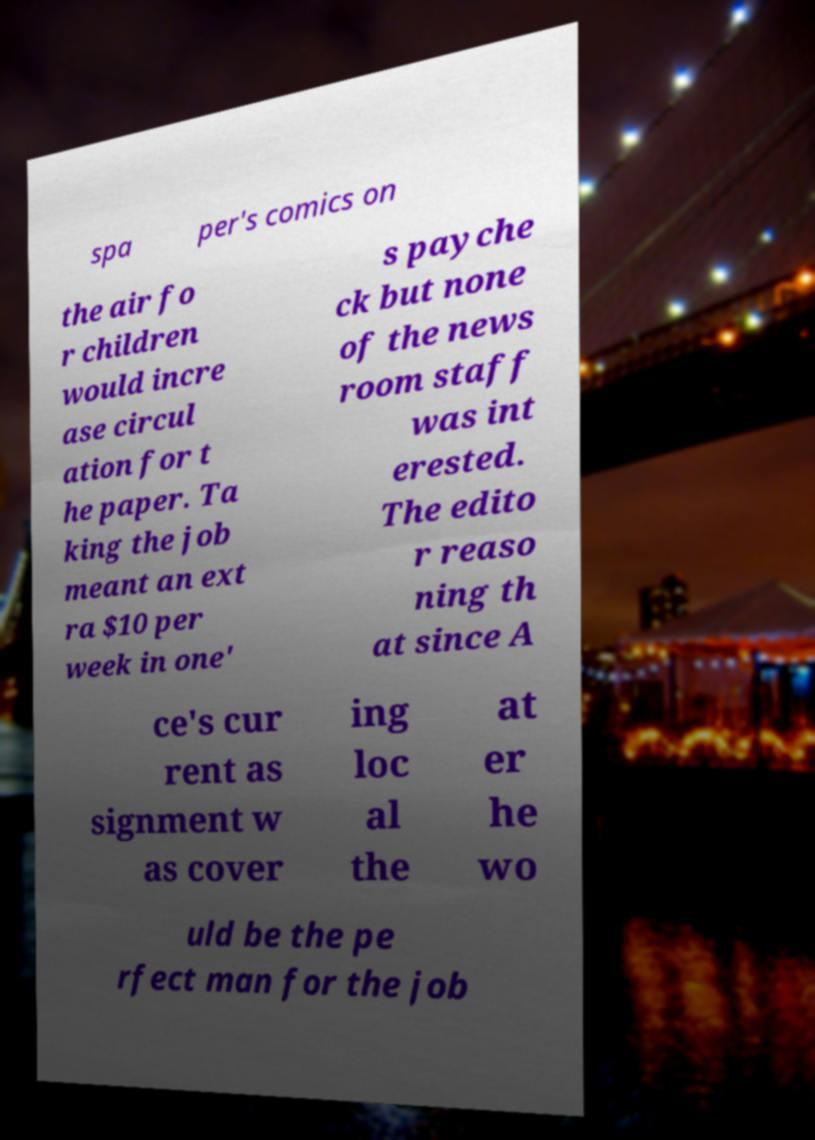Please read and relay the text visible in this image. What does it say? spa per's comics on the air fo r children would incre ase circul ation for t he paper. Ta king the job meant an ext ra $10 per week in one' s payche ck but none of the news room staff was int erested. The edito r reaso ning th at since A ce's cur rent as signment w as cover ing loc al the at er he wo uld be the pe rfect man for the job 